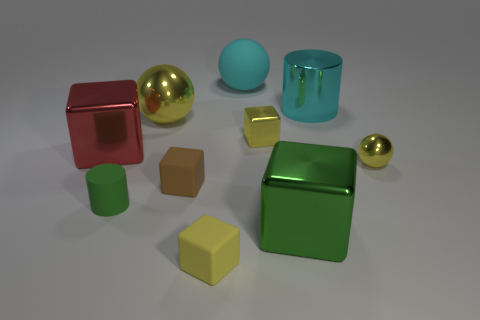Subtract all red cubes. How many cubes are left? 4 Subtract all big spheres. How many spheres are left? 1 Subtract all gray cubes. Subtract all gray balls. How many cubes are left? 5 Subtract all cylinders. How many objects are left? 8 Subtract 0 purple balls. How many objects are left? 10 Subtract all small matte things. Subtract all yellow blocks. How many objects are left? 5 Add 2 yellow matte things. How many yellow matte things are left? 3 Add 2 brown matte objects. How many brown matte objects exist? 3 